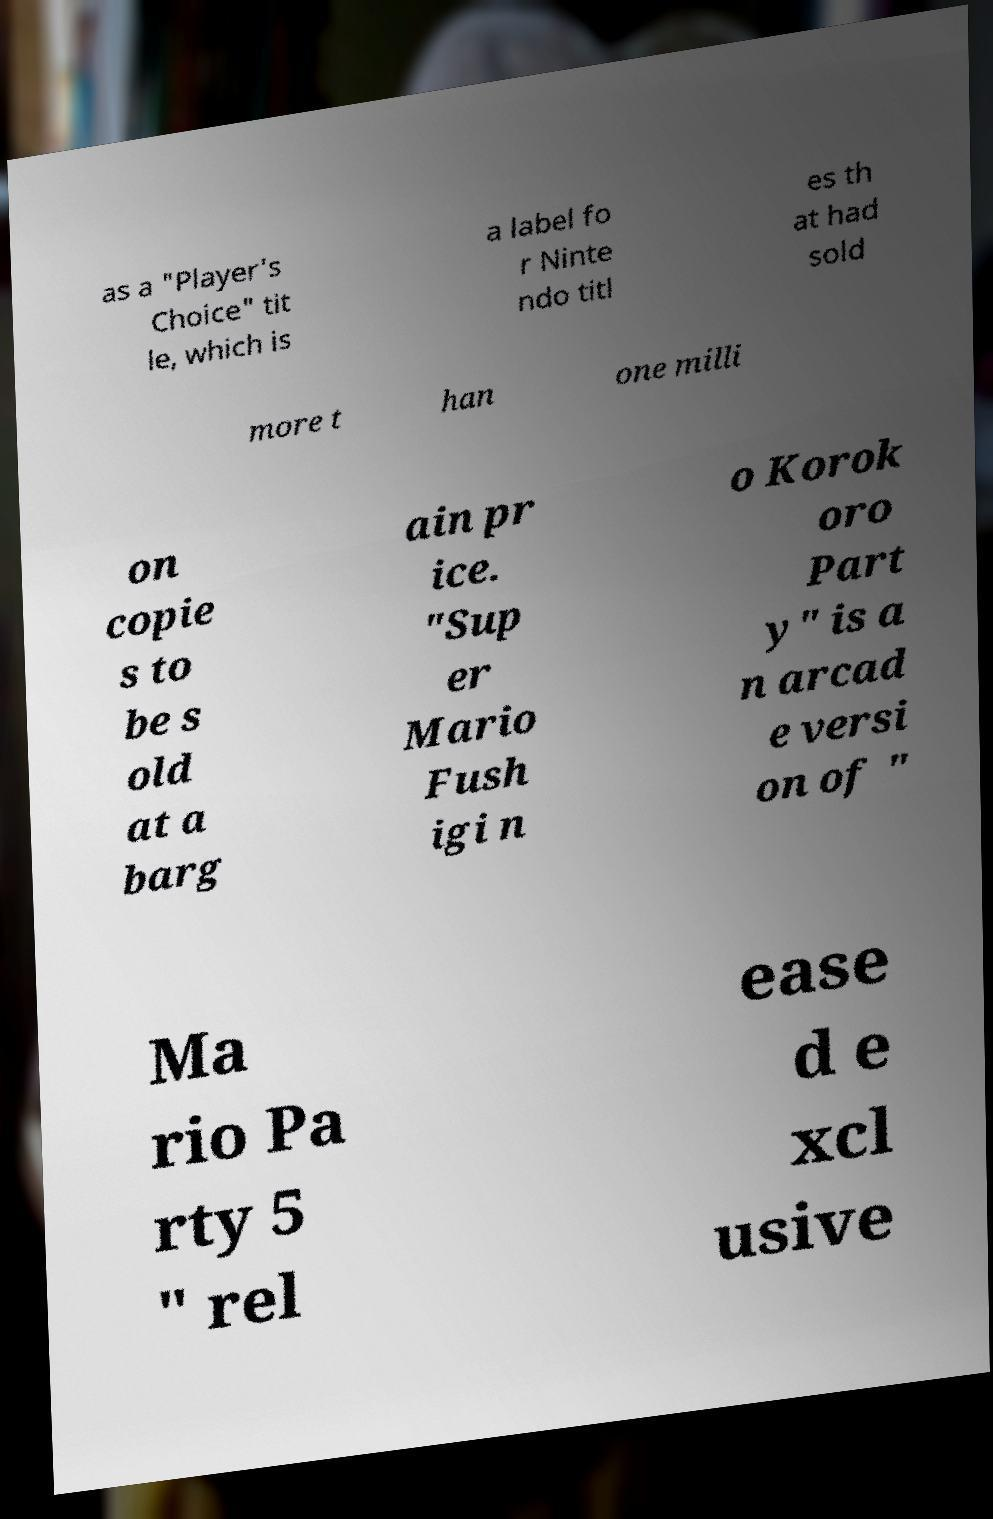For documentation purposes, I need the text within this image transcribed. Could you provide that? as a "Player's Choice" tit le, which is a label fo r Ninte ndo titl es th at had sold more t han one milli on copie s to be s old at a barg ain pr ice. "Sup er Mario Fush igi n o Korok oro Part y" is a n arcad e versi on of " Ma rio Pa rty 5 " rel ease d e xcl usive 